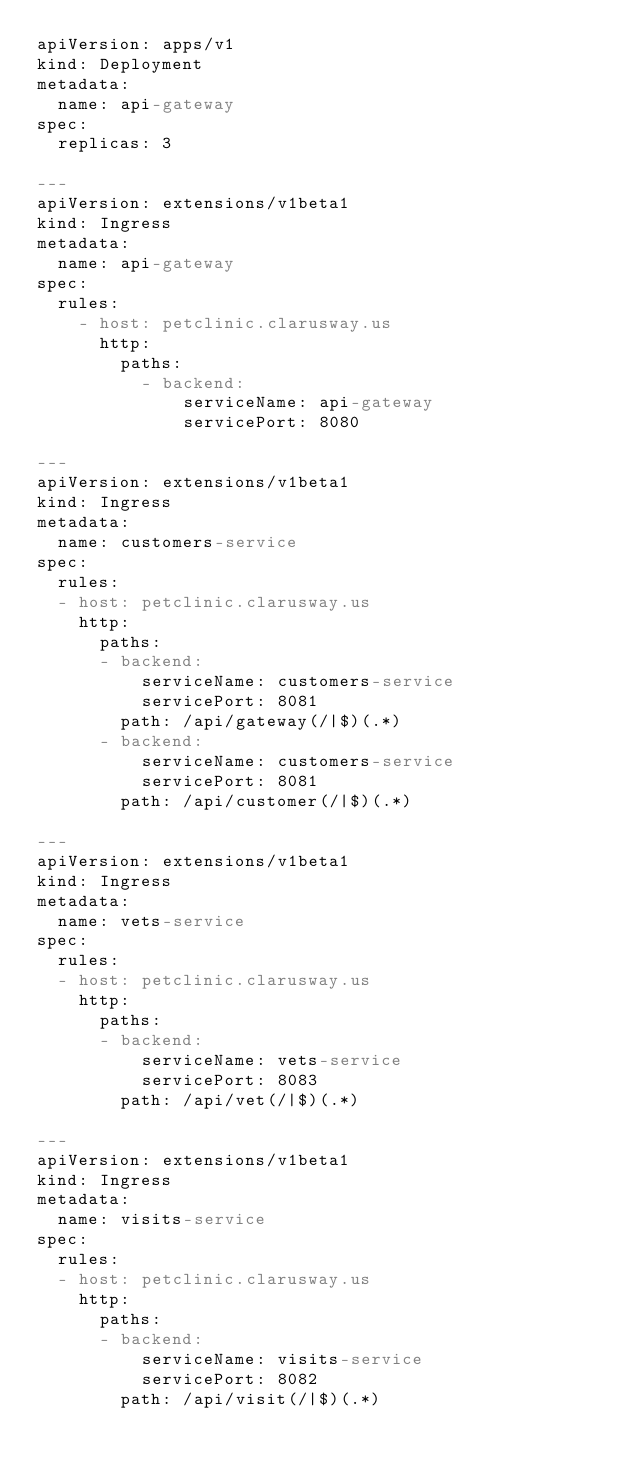<code> <loc_0><loc_0><loc_500><loc_500><_YAML_>apiVersion: apps/v1
kind: Deployment
metadata:
  name: api-gateway
spec:
  replicas: 3

---
apiVersion: extensions/v1beta1
kind: Ingress
metadata:
  name: api-gateway
spec:
  rules:
    - host: petclinic.clarusway.us
      http:
        paths:
          - backend:
              serviceName: api-gateway
              servicePort: 8080

---
apiVersion: extensions/v1beta1
kind: Ingress
metadata:
  name: customers-service
spec:
  rules:
  - host: petclinic.clarusway.us
    http:
      paths:
      - backend:
          serviceName: customers-service
          servicePort: 8081
        path: /api/gateway(/|$)(.*)
      - backend:
          serviceName: customers-service
          servicePort: 8081
        path: /api/customer(/|$)(.*)

---
apiVersion: extensions/v1beta1
kind: Ingress
metadata:
  name: vets-service
spec:
  rules:
  - host: petclinic.clarusway.us
    http:
      paths:
      - backend:
          serviceName: vets-service
          servicePort: 8083
        path: /api/vet(/|$)(.*)

---
apiVersion: extensions/v1beta1
kind: Ingress
metadata:
  name: visits-service
spec:
  rules:
  - host: petclinic.clarusway.us
    http:
      paths:
      - backend:
          serviceName: visits-service
          servicePort: 8082
        path: /api/visit(/|$)(.*)</code> 